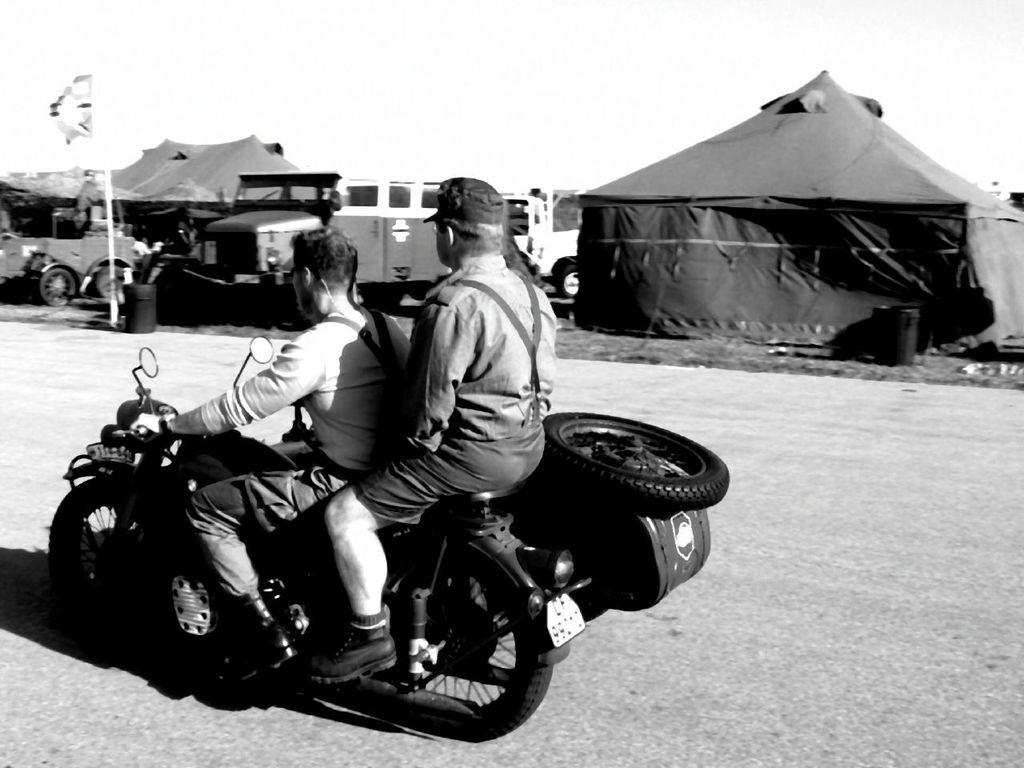How many people are in the image? There are two people in the image. What are the two people doing in the image? The two people are riding a vehicle. Can you describe the vehicle they are riding? The vehicle has a tube. What else can be seen in the image besides the people and the vehicle? There is a flag and tents in the image. Are there any other vehicles in the image? Yes, there are other vehicles in the image. What type of plants can be seen growing in the image? There are no plants visible in the image. 